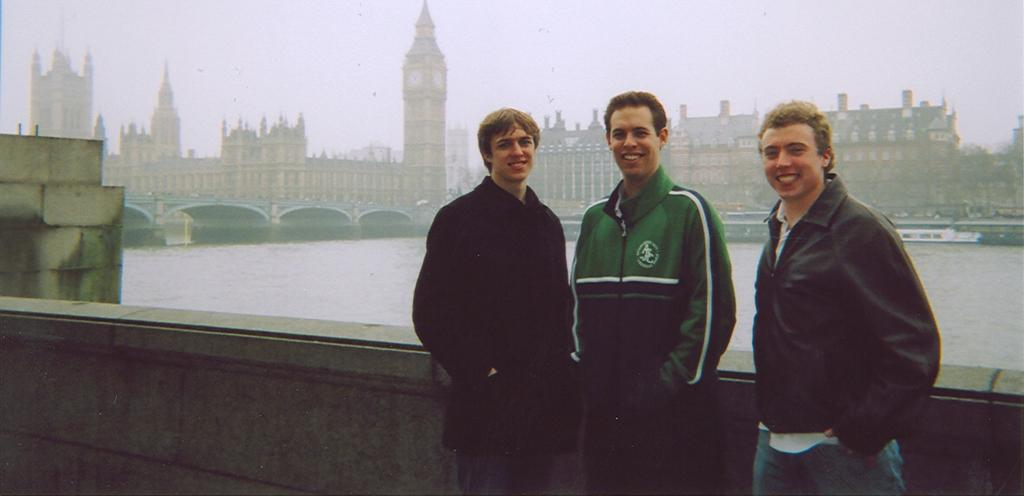How many people are in the image? There are three persons standing in the center of the image. What can be seen in the background of the image? There are buildings, a bridge, and water visible in the background of the image. What type of pickle is being used as a prop in the image? There is no pickle present in the image. Can you describe the frog's role in the image? There is no frog present in the image. 